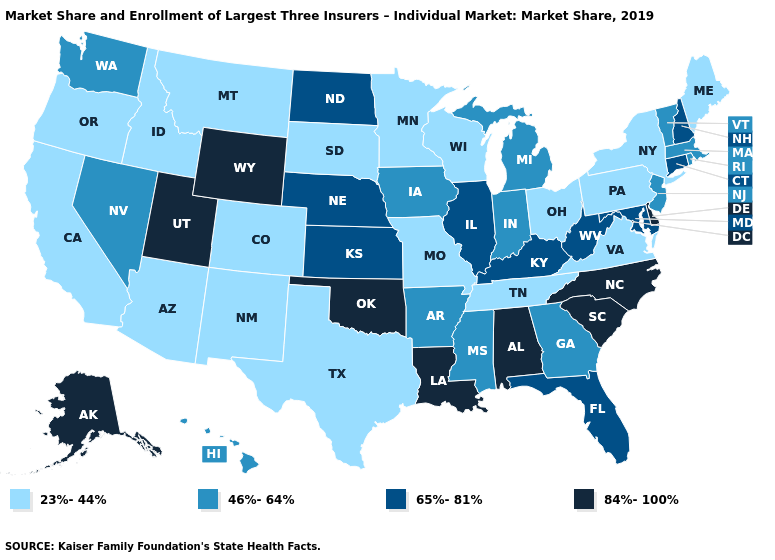What is the lowest value in the West?
Short answer required. 23%-44%. What is the highest value in the South ?
Concise answer only. 84%-100%. Name the states that have a value in the range 46%-64%?
Be succinct. Arkansas, Georgia, Hawaii, Indiana, Iowa, Massachusetts, Michigan, Mississippi, Nevada, New Jersey, Rhode Island, Vermont, Washington. Is the legend a continuous bar?
Keep it brief. No. Which states have the lowest value in the Northeast?
Quick response, please. Maine, New York, Pennsylvania. What is the lowest value in the MidWest?
Write a very short answer. 23%-44%. Name the states that have a value in the range 84%-100%?
Answer briefly. Alabama, Alaska, Delaware, Louisiana, North Carolina, Oklahoma, South Carolina, Utah, Wyoming. Name the states that have a value in the range 65%-81%?
Answer briefly. Connecticut, Florida, Illinois, Kansas, Kentucky, Maryland, Nebraska, New Hampshire, North Dakota, West Virginia. What is the value of Florida?
Quick response, please. 65%-81%. What is the value of Utah?
Answer briefly. 84%-100%. How many symbols are there in the legend?
Concise answer only. 4. Name the states that have a value in the range 65%-81%?
Be succinct. Connecticut, Florida, Illinois, Kansas, Kentucky, Maryland, Nebraska, New Hampshire, North Dakota, West Virginia. Does Delaware have the same value as Nevada?
Keep it brief. No. Name the states that have a value in the range 23%-44%?
Write a very short answer. Arizona, California, Colorado, Idaho, Maine, Minnesota, Missouri, Montana, New Mexico, New York, Ohio, Oregon, Pennsylvania, South Dakota, Tennessee, Texas, Virginia, Wisconsin. Name the states that have a value in the range 46%-64%?
Quick response, please. Arkansas, Georgia, Hawaii, Indiana, Iowa, Massachusetts, Michigan, Mississippi, Nevada, New Jersey, Rhode Island, Vermont, Washington. 